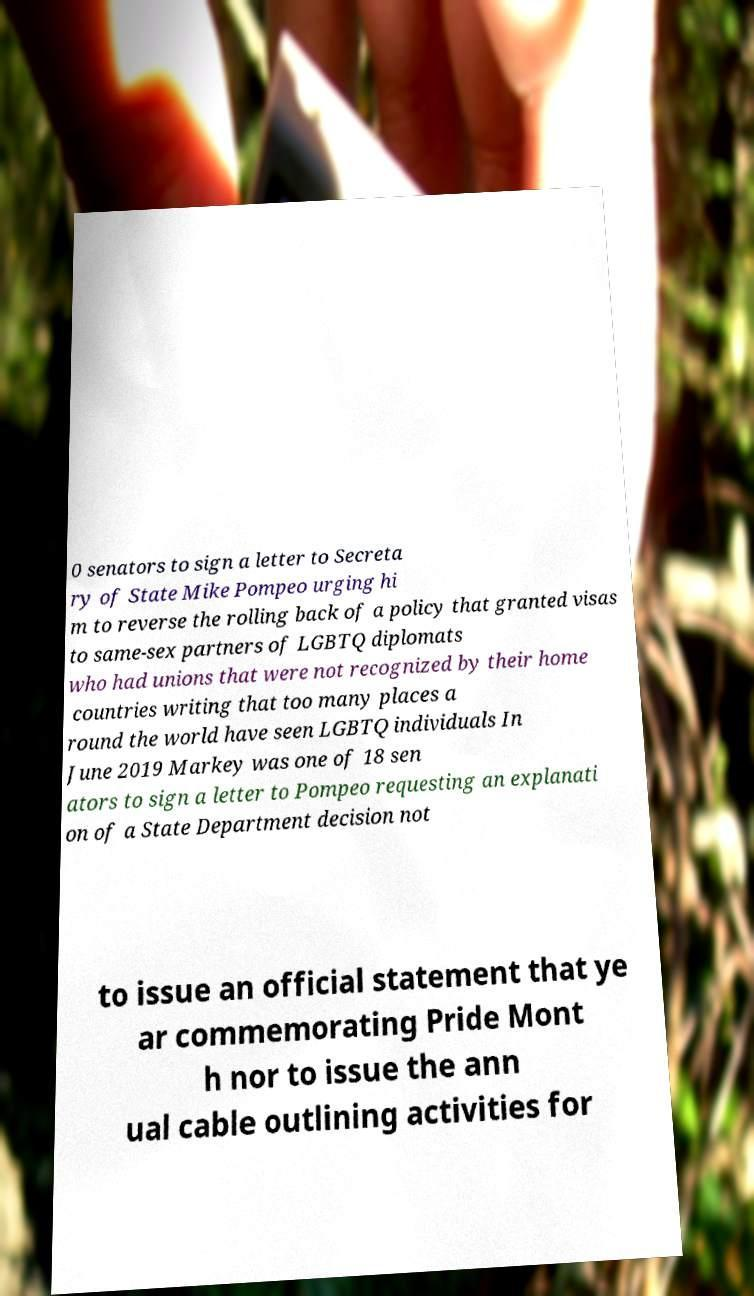Can you accurately transcribe the text from the provided image for me? 0 senators to sign a letter to Secreta ry of State Mike Pompeo urging hi m to reverse the rolling back of a policy that granted visas to same-sex partners of LGBTQ diplomats who had unions that were not recognized by their home countries writing that too many places a round the world have seen LGBTQ individuals In June 2019 Markey was one of 18 sen ators to sign a letter to Pompeo requesting an explanati on of a State Department decision not to issue an official statement that ye ar commemorating Pride Mont h nor to issue the ann ual cable outlining activities for 